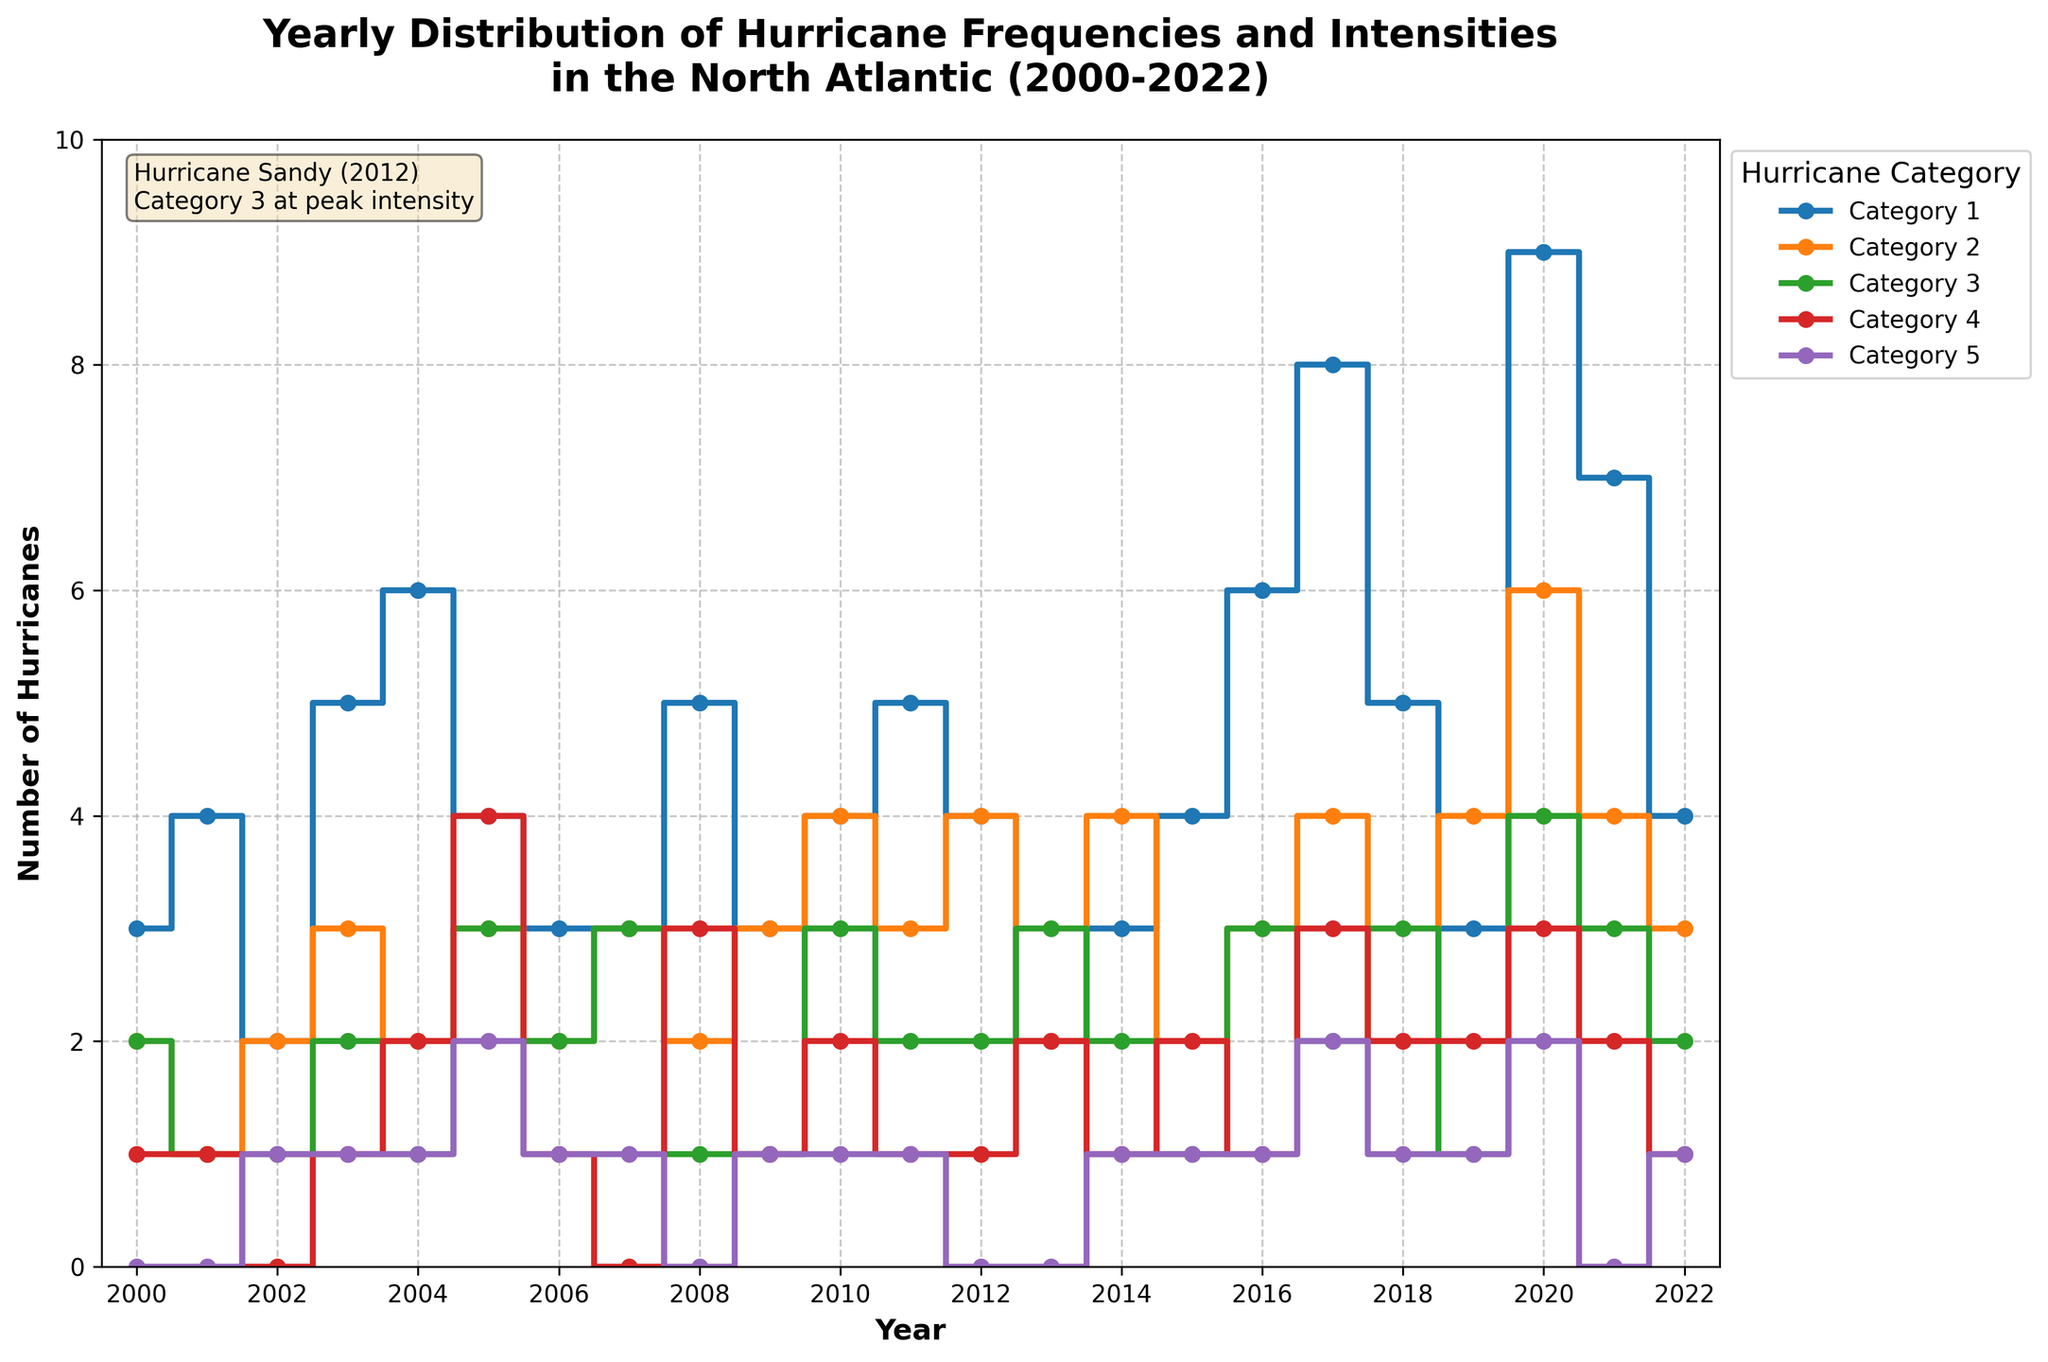Which year had the highest number of Category 5 hurricanes? Look at the stair steps for Category 5 and identify the year with the highest point. In 2005 and 2020, there were 2 Category 5 hurricanes, which is the highest.
Answer: 2005 and 2020 What is the total number of hurricanes in 2017 across all categories? Sum the number of hurricanes in each category for the year 2017: 8 (Category 1) + 4 (Category 2) + 2 (Category 3) + 3 (Category 4) + 2 (Category 5) = 19.
Answer: 19 How many more Category 1 hurricanes were there in 2020 compared to 2010? Subtract the number of Category 1 hurricanes in 2010 from the number in 2020: 9 (2020) - 4 (2010) = 5.
Answer: 5 In which year did Category 4 hurricanes peak within the given time frame? Look at the stair steps for Category 4 hurricanes and find the year with the highest point. In 2005 and 2020, there were 4 Category 4 hurricanes, the maximum.
Answer: 2005 and 2020 Which category had the least overall hurricanes from 2000 to 2022? Compare the stair steps of each category and find the category with the consistently lower values. Category 5 has fewer hurricanes most years.
Answer: Category 5 Between 2012 and 2017, which year had the lowest number of Category 3 hurricanes? Review the stair plot for Category 3 hurricanes from 2012 to 2017. In 2016 and 2017, there were 2 Category 3 hurricanes, which is the lowest in this range.
Answer: 2016 and 2017 Has there ever been a year without any Category 2 hurricanes? Check the stair step line for Category 2 hurricanes to see if it ever drops to zero. No year has zero Category 2 hurricanes.
Answer: No What is the average number of Category 1 hurricanes per year? Sum the number of Category 1 hurricanes for all years and divide by the number of years: (3+4+2+5+6+4+3+3+5+3+4+5+4+2+3+4+6+8+5+3+9+7+4) / 23 = 4.3.
Answer: 4.3 Compare the number of Category 4 hurricanes in 2005 and 2012. The stair step for Category 4 shows 4 hurricanes in 2005 and 1 in 2012.
Answer: 2005 had more Category 4 hurricanes 